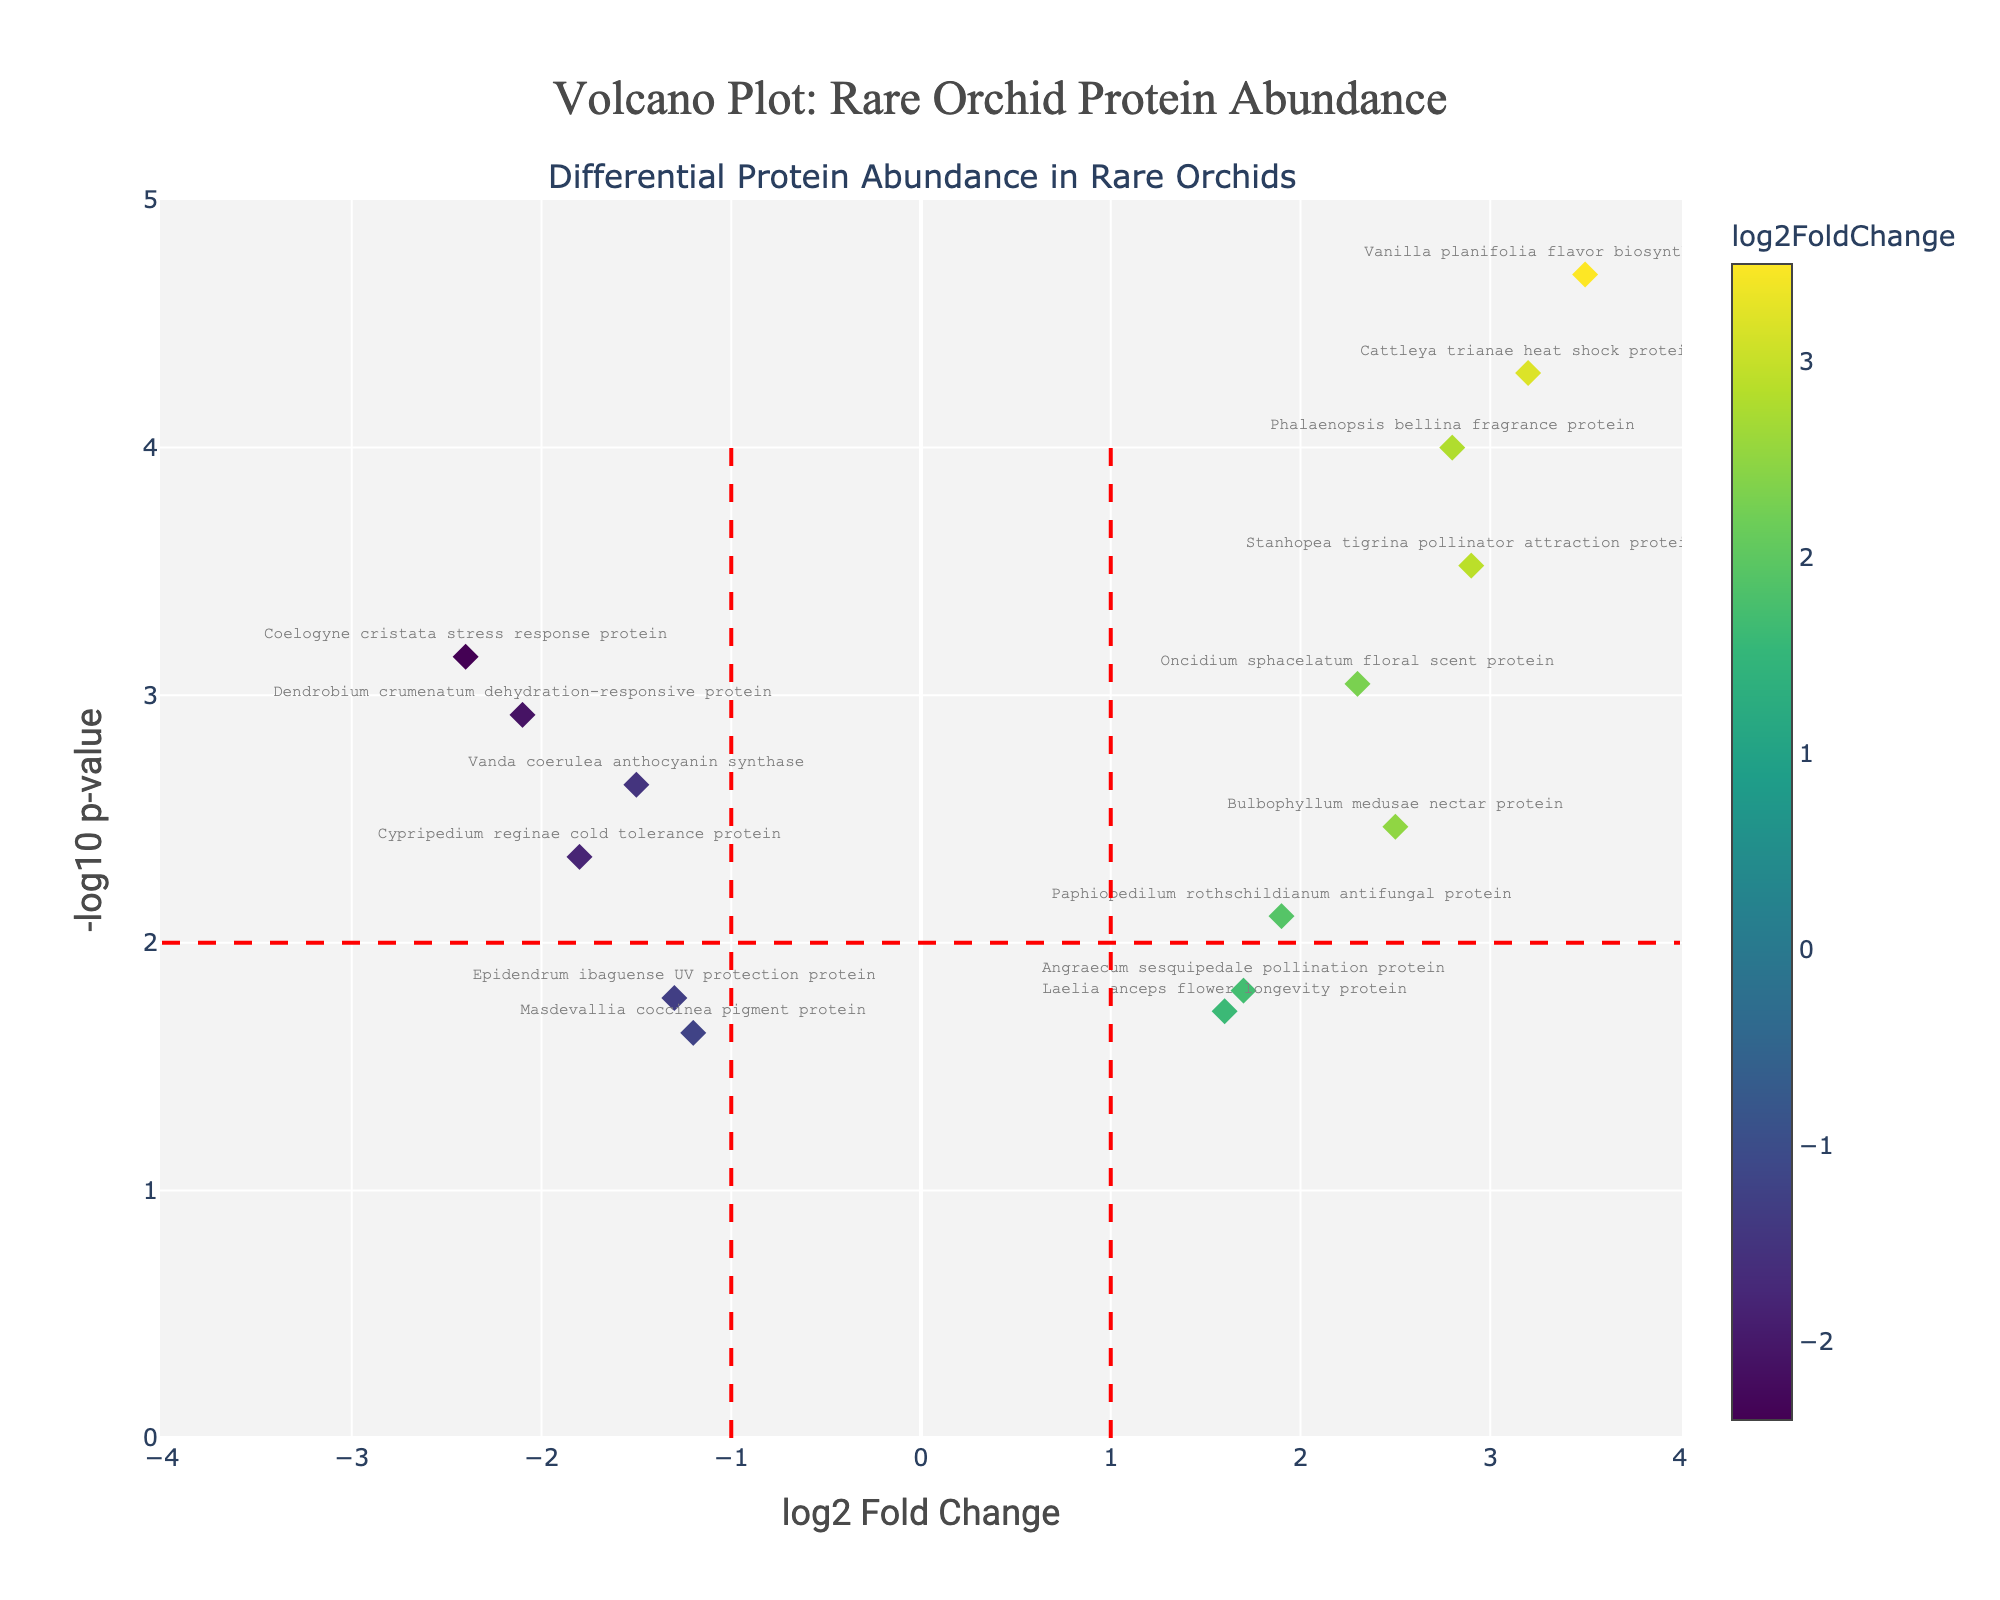What is the title of the volcano plot? The title is located at the top of the figure and is the largest text in the plot. It gives an overview of what the plot represents.
Answer: Volcano Plot: Rare Orchid Protein Abundance How many proteins have a log2 fold change greater than 3? Count the number of data points that are located to the right of the vertical line at log2 fold change of 3 in the figure.
Answer: 1 Which protein has the highest log2 fold change? Identify the data point with the highest x-axis value (log2 fold change) in the figure.
Answer: Vanilla planifolia flavor biosynthesis protein What color represents proteins with negative log2 fold changes? Observe the colors used in the plot. Negative log2 fold changes are often shown in dark colors.
Answer: Dark colors How many proteins have a p-value less than 0.001? Find the data points that are above the horizontal line marking -log10(p-value) of 3 (since -log10(0.001) = 3) in the figure.
Answer: 4 Which protein is associated with dehydration response? Look for the label of the data point related to the "dehydration-responsive protein" on the figure.
Answer: Dendrobium crumenatum dehydration-responsive protein Are there more proteins with a positive or negative log2 fold change? Compare the number of data points to the right (positive) versus the left (negative) of the vertical line at log2 fold change of 0 in the figure.
Answer: Positive What are the axes labels in the plot? Read the text next to the x and y axes on the plot. The x-axis shows the change in protein levels, and the y-axis shows the significance of the change.
Answer: x-axis: log2 Fold Change, y-axis: -log10 p-value Which protein has the smallest p-value? Identify the data point with the highest y-axis value (-log10 p-value) in the figure.
Answer: Vanilla planifolia flavor biosynthesis protein 